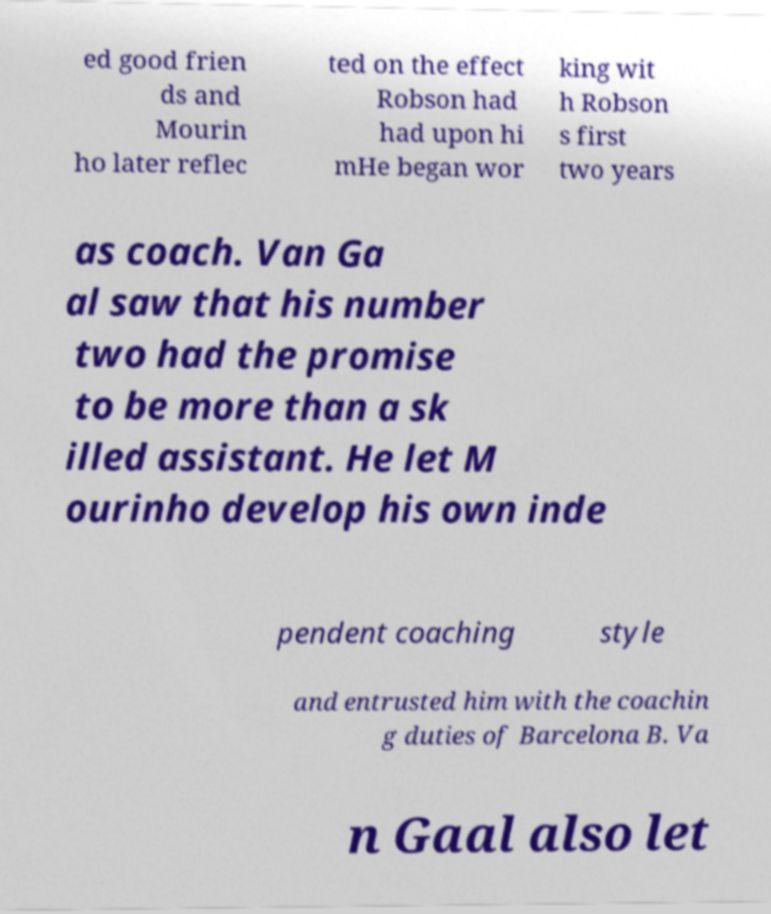Can you read and provide the text displayed in the image?This photo seems to have some interesting text. Can you extract and type it out for me? ed good frien ds and Mourin ho later reflec ted on the effect Robson had had upon hi mHe began wor king wit h Robson s first two years as coach. Van Ga al saw that his number two had the promise to be more than a sk illed assistant. He let M ourinho develop his own inde pendent coaching style and entrusted him with the coachin g duties of Barcelona B. Va n Gaal also let 